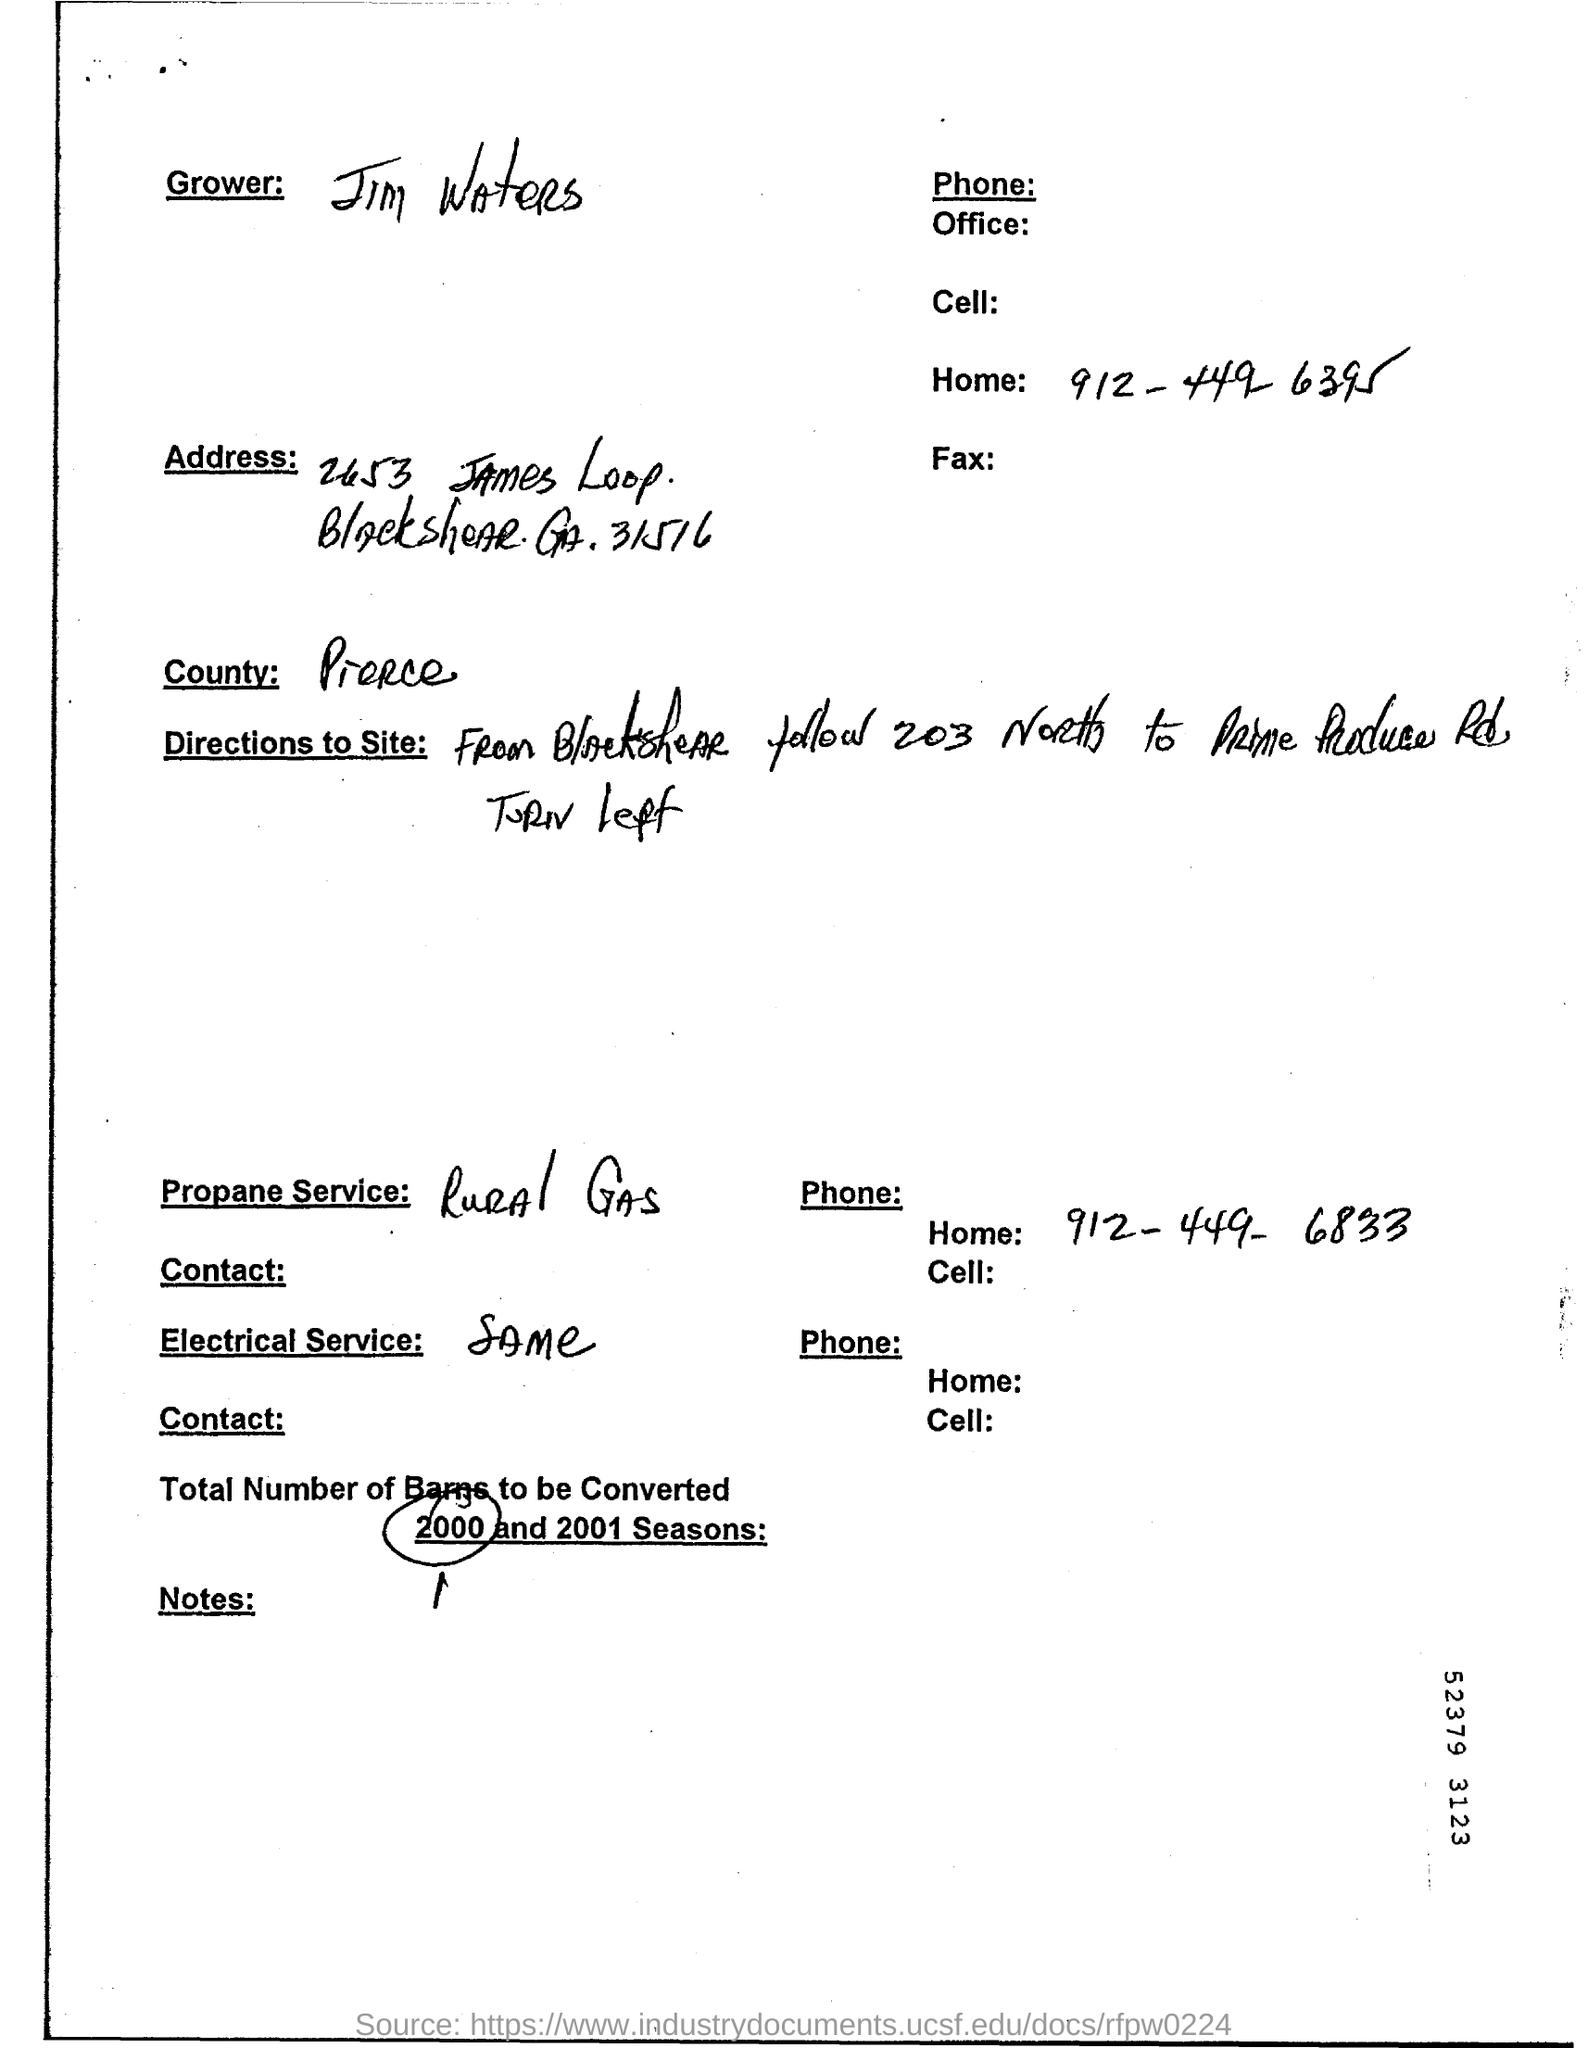Specify some key components in this picture. The home phone number for Jim Waters is 912-449-6395. The Phone for Rural Gas is 912-449-6833. The propane service is Rural Gas. The speaker is declaring that the grower is named Jim Waters. 